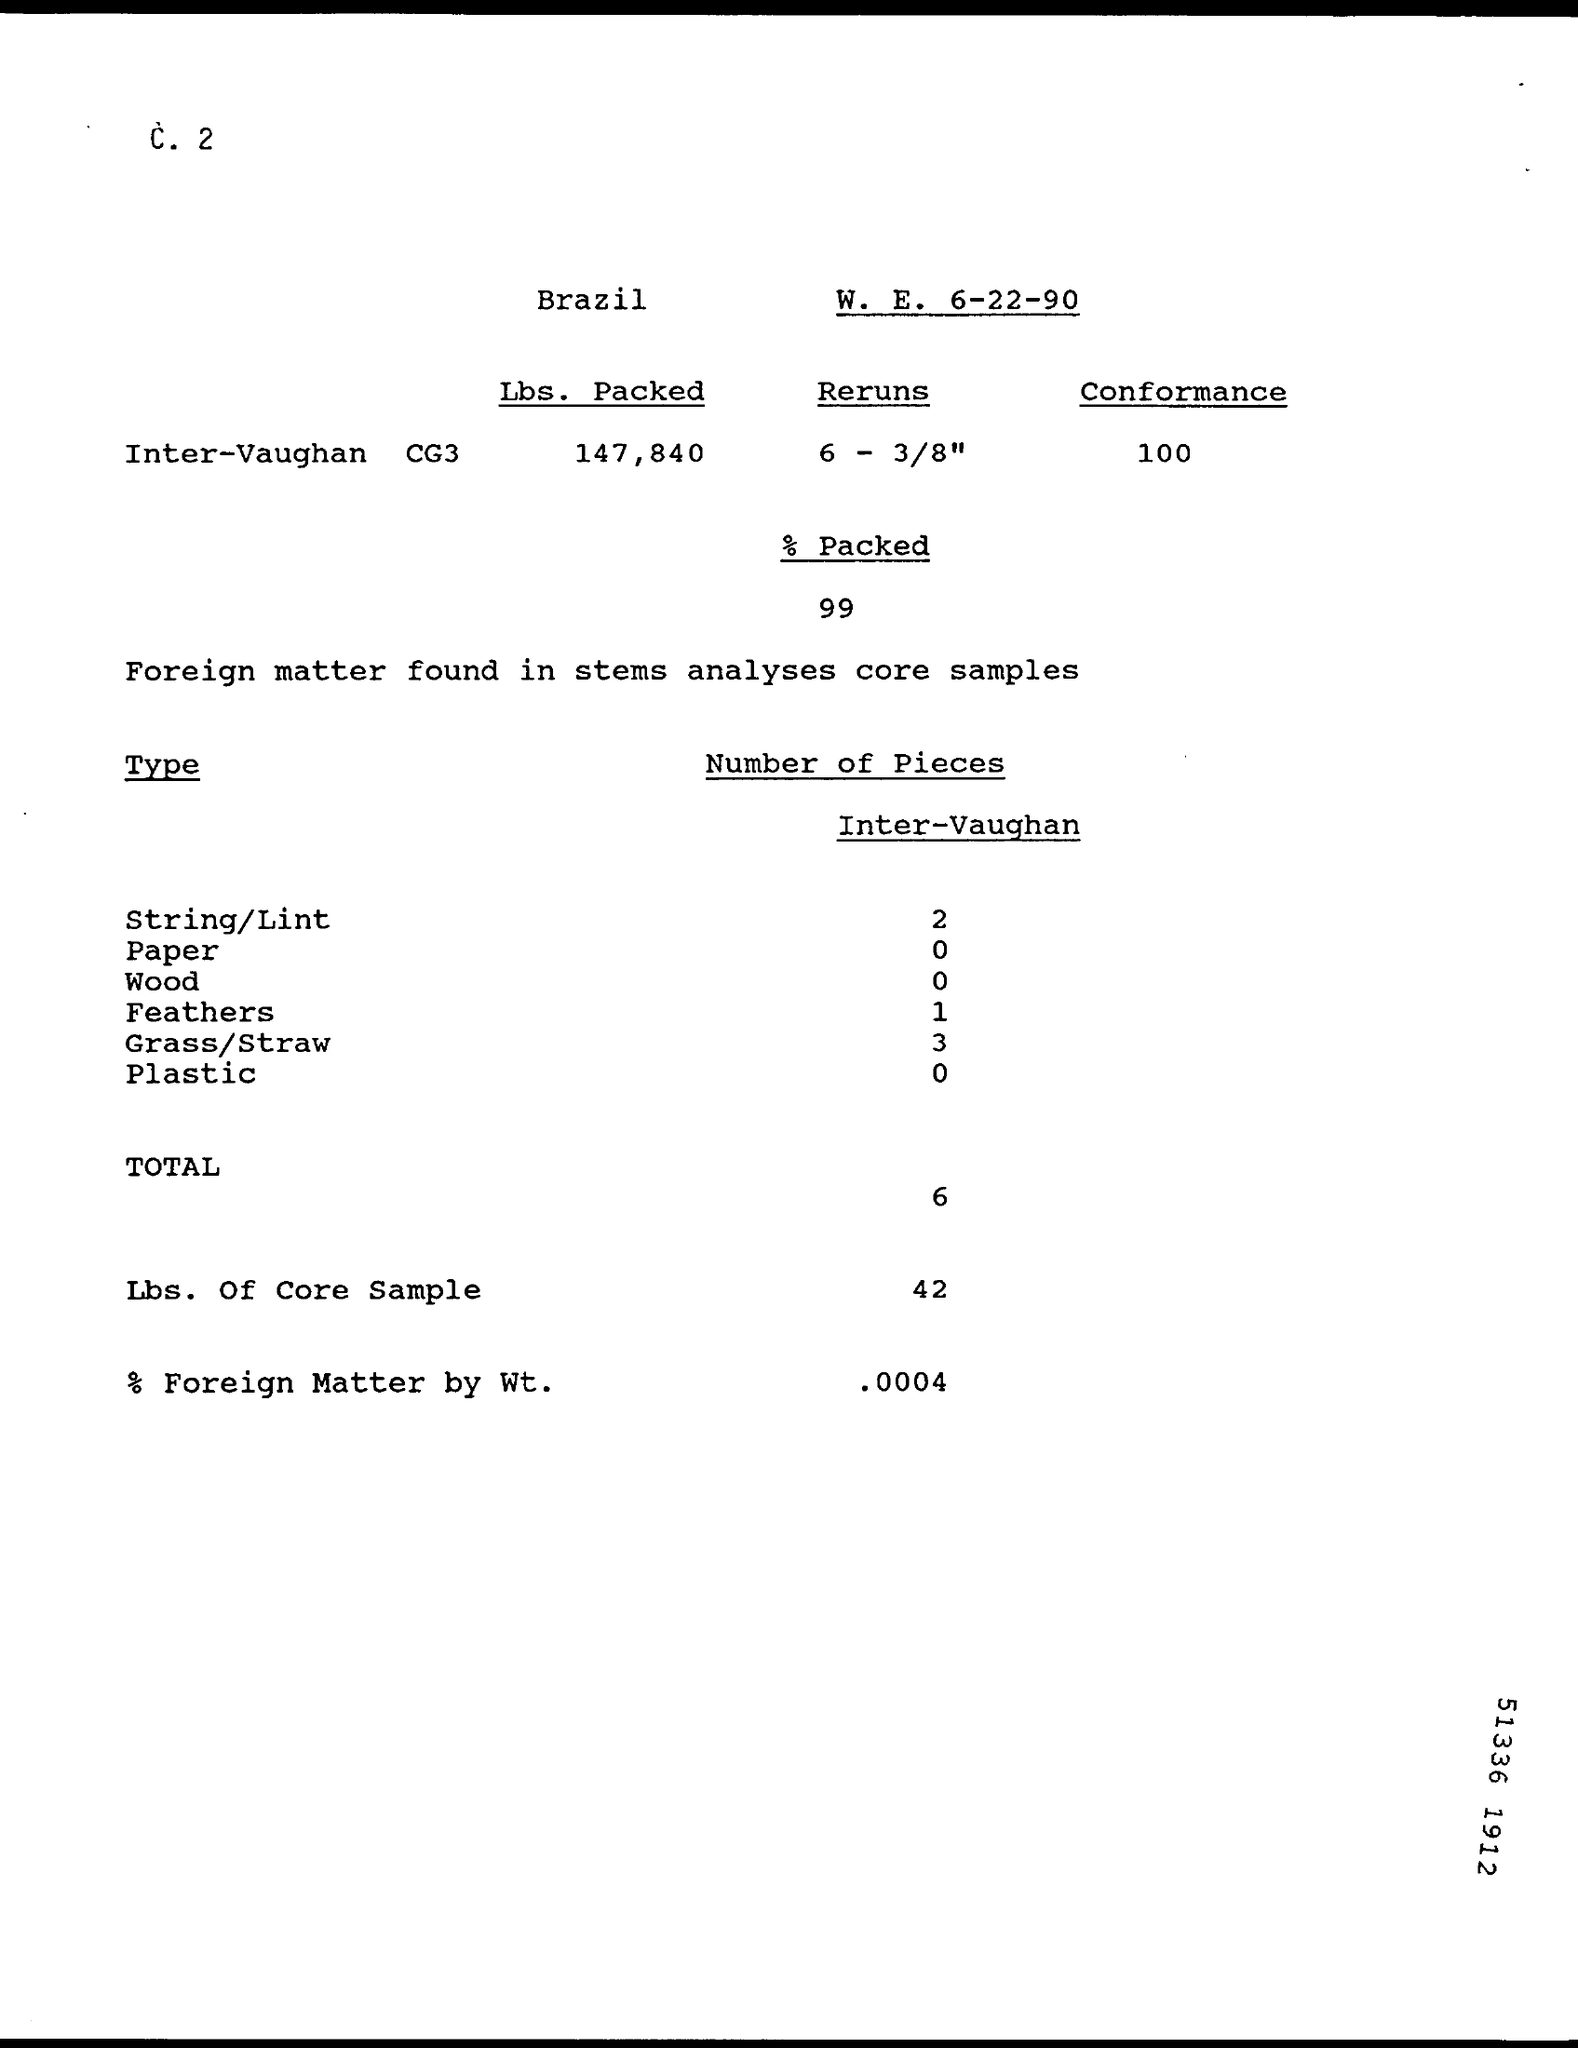Identify some key points in this picture. The foreign matter by weight accounted for 0.0004% of the total sample. The weight in Lbs. of a core sample is 42. The sample was found to contain three pieces of grass/straw. 